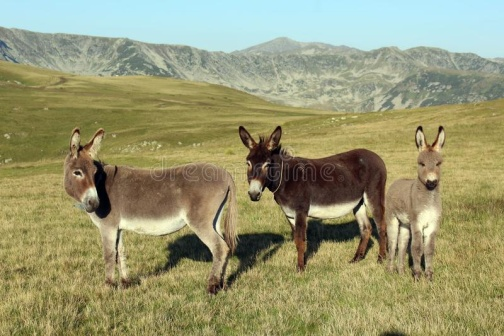What can be inferred about the time of day and season from the image? The length and direction of the shadows suggest it might be either morning or late afternoon, where the sun is low in the sky. The vibrant green grass and the clear skies hint that the season could be spring or early summer, as the lushness of the grass indicates a period of active growth and favorable weather conditions. 